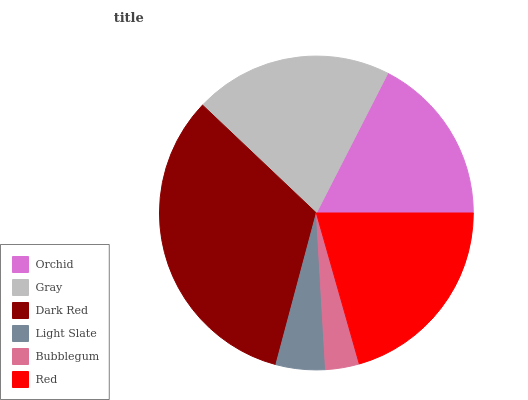Is Bubblegum the minimum?
Answer yes or no. Yes. Is Dark Red the maximum?
Answer yes or no. Yes. Is Gray the minimum?
Answer yes or no. No. Is Gray the maximum?
Answer yes or no. No. Is Gray greater than Orchid?
Answer yes or no. Yes. Is Orchid less than Gray?
Answer yes or no. Yes. Is Orchid greater than Gray?
Answer yes or no. No. Is Gray less than Orchid?
Answer yes or no. No. Is Gray the high median?
Answer yes or no. Yes. Is Orchid the low median?
Answer yes or no. Yes. Is Orchid the high median?
Answer yes or no. No. Is Bubblegum the low median?
Answer yes or no. No. 